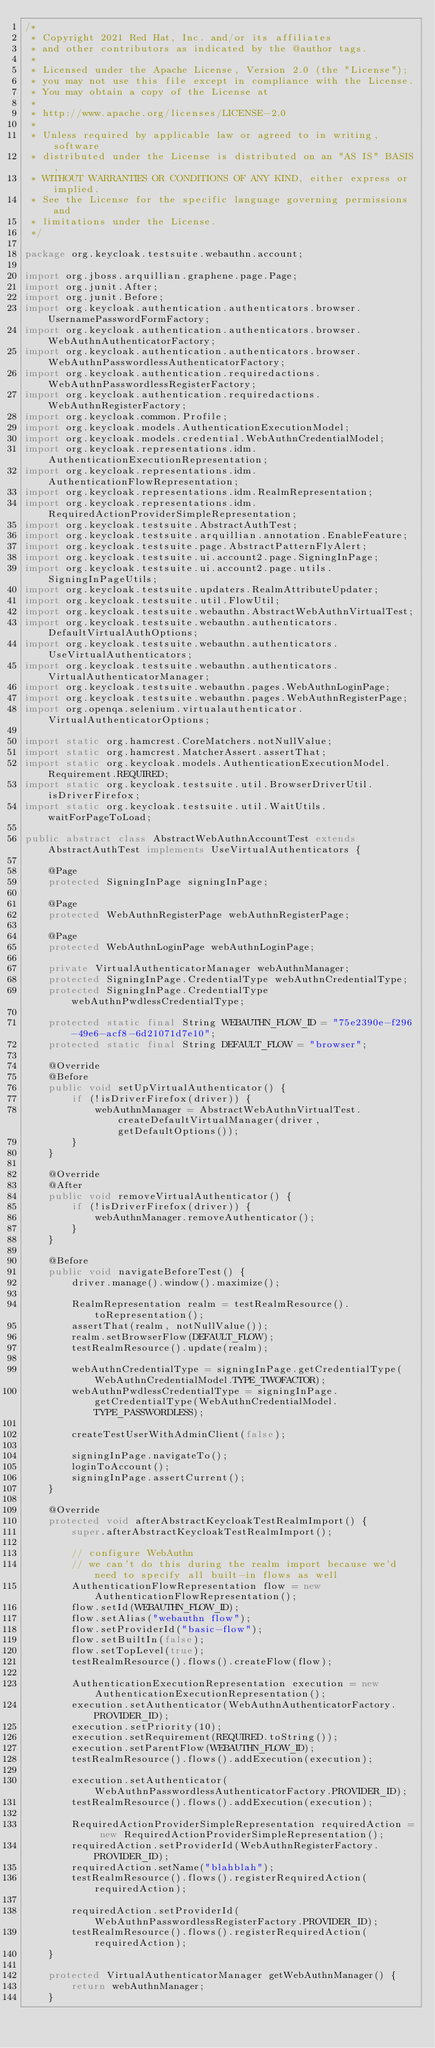Convert code to text. <code><loc_0><loc_0><loc_500><loc_500><_Java_>/*
 * Copyright 2021 Red Hat, Inc. and/or its affiliates
 * and other contributors as indicated by the @author tags.
 *
 * Licensed under the Apache License, Version 2.0 (the "License");
 * you may not use this file except in compliance with the License.
 * You may obtain a copy of the License at
 *
 * http://www.apache.org/licenses/LICENSE-2.0
 *
 * Unless required by applicable law or agreed to in writing, software
 * distributed under the License is distributed on an "AS IS" BASIS,
 * WITHOUT WARRANTIES OR CONDITIONS OF ANY KIND, either express or implied.
 * See the License for the specific language governing permissions and
 * limitations under the License.
 */

package org.keycloak.testsuite.webauthn.account;

import org.jboss.arquillian.graphene.page.Page;
import org.junit.After;
import org.junit.Before;
import org.keycloak.authentication.authenticators.browser.UsernamePasswordFormFactory;
import org.keycloak.authentication.authenticators.browser.WebAuthnAuthenticatorFactory;
import org.keycloak.authentication.authenticators.browser.WebAuthnPasswordlessAuthenticatorFactory;
import org.keycloak.authentication.requiredactions.WebAuthnPasswordlessRegisterFactory;
import org.keycloak.authentication.requiredactions.WebAuthnRegisterFactory;
import org.keycloak.common.Profile;
import org.keycloak.models.AuthenticationExecutionModel;
import org.keycloak.models.credential.WebAuthnCredentialModel;
import org.keycloak.representations.idm.AuthenticationExecutionRepresentation;
import org.keycloak.representations.idm.AuthenticationFlowRepresentation;
import org.keycloak.representations.idm.RealmRepresentation;
import org.keycloak.representations.idm.RequiredActionProviderSimpleRepresentation;
import org.keycloak.testsuite.AbstractAuthTest;
import org.keycloak.testsuite.arquillian.annotation.EnableFeature;
import org.keycloak.testsuite.page.AbstractPatternFlyAlert;
import org.keycloak.testsuite.ui.account2.page.SigningInPage;
import org.keycloak.testsuite.ui.account2.page.utils.SigningInPageUtils;
import org.keycloak.testsuite.updaters.RealmAttributeUpdater;
import org.keycloak.testsuite.util.FlowUtil;
import org.keycloak.testsuite.webauthn.AbstractWebAuthnVirtualTest;
import org.keycloak.testsuite.webauthn.authenticators.DefaultVirtualAuthOptions;
import org.keycloak.testsuite.webauthn.authenticators.UseVirtualAuthenticators;
import org.keycloak.testsuite.webauthn.authenticators.VirtualAuthenticatorManager;
import org.keycloak.testsuite.webauthn.pages.WebAuthnLoginPage;
import org.keycloak.testsuite.webauthn.pages.WebAuthnRegisterPage;
import org.openqa.selenium.virtualauthenticator.VirtualAuthenticatorOptions;

import static org.hamcrest.CoreMatchers.notNullValue;
import static org.hamcrest.MatcherAssert.assertThat;
import static org.keycloak.models.AuthenticationExecutionModel.Requirement.REQUIRED;
import static org.keycloak.testsuite.util.BrowserDriverUtil.isDriverFirefox;
import static org.keycloak.testsuite.util.WaitUtils.waitForPageToLoad;

public abstract class AbstractWebAuthnAccountTest extends AbstractAuthTest implements UseVirtualAuthenticators {

    @Page
    protected SigningInPage signingInPage;

    @Page
    protected WebAuthnRegisterPage webAuthnRegisterPage;

    @Page
    protected WebAuthnLoginPage webAuthnLoginPage;

    private VirtualAuthenticatorManager webAuthnManager;
    protected SigningInPage.CredentialType webAuthnCredentialType;
    protected SigningInPage.CredentialType webAuthnPwdlessCredentialType;

    protected static final String WEBAUTHN_FLOW_ID = "75e2390e-f296-49e6-acf8-6d21071d7e10";
    protected static final String DEFAULT_FLOW = "browser";

    @Override
    @Before
    public void setUpVirtualAuthenticator() {
        if (!isDriverFirefox(driver)) {
            webAuthnManager = AbstractWebAuthnVirtualTest.createDefaultVirtualManager(driver, getDefaultOptions());
        }
    }

    @Override
    @After
    public void removeVirtualAuthenticator() {
        if (!isDriverFirefox(driver)) {
            webAuthnManager.removeAuthenticator();
        }
    }

    @Before
    public void navigateBeforeTest() {
        driver.manage().window().maximize();

        RealmRepresentation realm = testRealmResource().toRepresentation();
        assertThat(realm, notNullValue());
        realm.setBrowserFlow(DEFAULT_FLOW);
        testRealmResource().update(realm);

        webAuthnCredentialType = signingInPage.getCredentialType(WebAuthnCredentialModel.TYPE_TWOFACTOR);
        webAuthnPwdlessCredentialType = signingInPage.getCredentialType(WebAuthnCredentialModel.TYPE_PASSWORDLESS);

        createTestUserWithAdminClient(false);

        signingInPage.navigateTo();
        loginToAccount();
        signingInPage.assertCurrent();
    }

    @Override
    protected void afterAbstractKeycloakTestRealmImport() {
        super.afterAbstractKeycloakTestRealmImport();

        // configure WebAuthn
        // we can't do this during the realm import because we'd need to specify all built-in flows as well
        AuthenticationFlowRepresentation flow = new AuthenticationFlowRepresentation();
        flow.setId(WEBAUTHN_FLOW_ID);
        flow.setAlias("webauthn flow");
        flow.setProviderId("basic-flow");
        flow.setBuiltIn(false);
        flow.setTopLevel(true);
        testRealmResource().flows().createFlow(flow);

        AuthenticationExecutionRepresentation execution = new AuthenticationExecutionRepresentation();
        execution.setAuthenticator(WebAuthnAuthenticatorFactory.PROVIDER_ID);
        execution.setPriority(10);
        execution.setRequirement(REQUIRED.toString());
        execution.setParentFlow(WEBAUTHN_FLOW_ID);
        testRealmResource().flows().addExecution(execution);

        execution.setAuthenticator(WebAuthnPasswordlessAuthenticatorFactory.PROVIDER_ID);
        testRealmResource().flows().addExecution(execution);

        RequiredActionProviderSimpleRepresentation requiredAction = new RequiredActionProviderSimpleRepresentation();
        requiredAction.setProviderId(WebAuthnRegisterFactory.PROVIDER_ID);
        requiredAction.setName("blahblah");
        testRealmResource().flows().registerRequiredAction(requiredAction);

        requiredAction.setProviderId(WebAuthnPasswordlessRegisterFactory.PROVIDER_ID);
        testRealmResource().flows().registerRequiredAction(requiredAction);
    }

    protected VirtualAuthenticatorManager getWebAuthnManager() {
        return webAuthnManager;
    }
</code> 